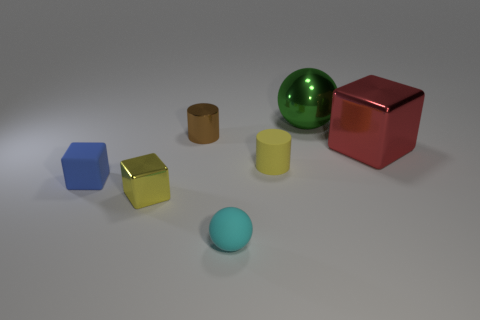There is a big object in front of the green metallic ball; what is its shape?
Provide a short and direct response. Cube. Is the number of large brown shiny cylinders less than the number of rubber spheres?
Make the answer very short. Yes. Do the sphere in front of the small brown metal cylinder and the tiny blue cube have the same material?
Ensure brevity in your answer.  Yes. Is there anything else that is the same size as the cyan matte object?
Your response must be concise. Yes. Are there any small rubber cylinders to the right of the small yellow cylinder?
Your response must be concise. No. There is a small cylinder in front of the small thing behind the metal cube right of the yellow matte cylinder; what color is it?
Your answer should be very brief. Yellow. What shape is the brown thing that is the same size as the matte block?
Your answer should be very brief. Cylinder. Are there more large red metal cubes than cubes?
Give a very brief answer. No. There is a tiny block that is right of the small blue rubber cube; is there a tiny blue rubber object right of it?
Your answer should be compact. No. There is a big object that is the same shape as the small blue object; what color is it?
Make the answer very short. Red. 